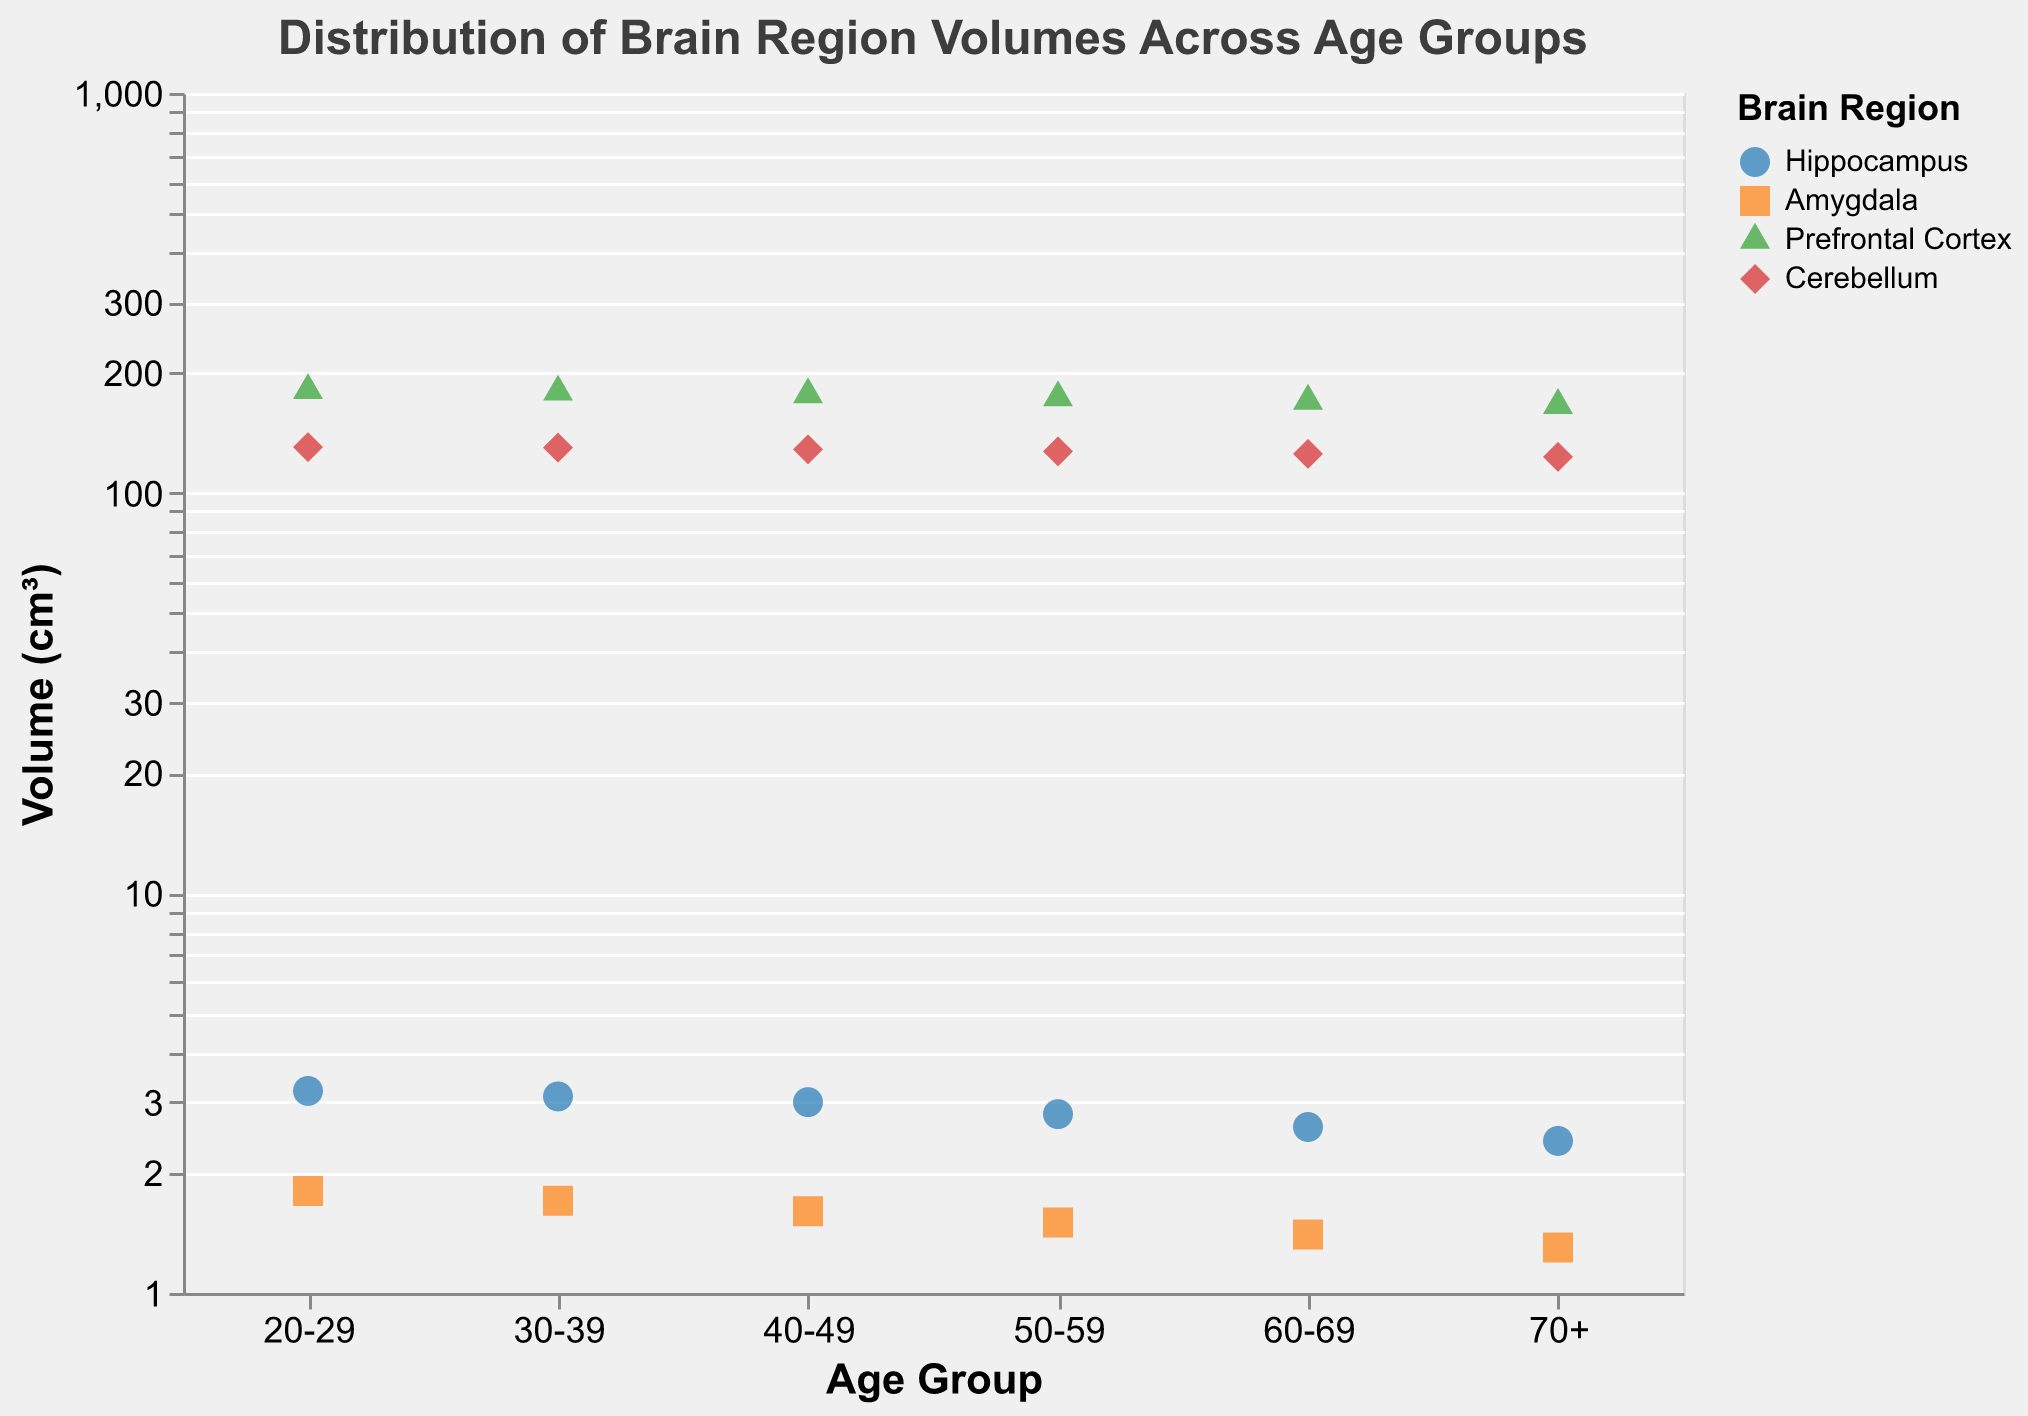How many brain regions are shown for each age group? There are four distinct brain regions: Hippocampus, Amygdala, Prefrontal Cortex, and Cerebellum listed for each age group.
Answer: 4 Which age group has the largest hippocampus volume? To determine this, look at the Hippocampus data points across all age groups and identify which has the highest volume. The highest hippocampus volume is 3.2 cm³ in the 20-29 group.
Answer: 20-29 What is the smallest amygdala volume in the plot? Compare the volumes of the Amygdala across all age groups to find the minimum value, which is 1.3 cm³ in the 70+ group.
Answer: 1.3 cm³ How do the volumes of the Prefrontal Cortex change as age increases? Observe the Prefrontal Cortex volumes across age groups. The volumes decrease as age increases: 180.5 cm³ (20-29), 178.9 cm³ (30-39), 176.2 cm³ (40-49), 173.1 cm³ (50-59), 169.8 cm³ (60-69), and 165.7 cm³ (70+).
Answer: They decrease Which brain region shows the most significant decrease in volume from age group 20-29 to age group 70+? Calculate the difference in volume for each brain region between the 20-29 and 70+ age groups: Hippocampus (3.2 - 2.4 = 0.8 cm³), Amygdala (1.8 - 1.3 = 0.5 cm³), Prefrontal Cortex (180.5 - 165.7 = 14.8 cm³), Cerebellum (130.2 - 123.1 = 7.1 cm³). The most significant decrease is for the Prefrontal Cortex with a change of 14.8 cm³.
Answer: Prefrontal Cortex Between which consecutive age groups is the decrease in Cerebellum volume the highest? Calculate the differences in Cerebellum volume between consecutive age groups: 20-29 to 30-39 (130.2 - 129.8 = 0.4 cm³), 30-39 to 40-49 (129.8 - 128.5 = 1.3 cm³), 40-49 to 50-59 (128.5 - 127.0 = 1.5 cm³), 50-59 to 60-69 (127.0 - 125.3 = 1.7 cm³), 60-69 to 70+ (125.3 - 123.1 = 2.2 cm³). The highest decrease is between 60-69 and 70+ with a change of 2.2 cm³.
Answer: 60-69 to 70+ What trend do you observe in the hippocampus volume across different age groups? The hippocampus volume shows a decreasing trend: 3.2 cm³ (20-29), 3.1 cm³ (30-39), 3.0 cm³ (40-49), 2.8 cm³ (50-59), 2.6 cm³ (60-69), and 2.4 cm³ (70+).
Answer: Decreasing trend Does any brain region maintain a constant volume across age groups? By inspecting the plot, we observe that none of the brain regions maintain a constant volume, as all show some degree of fluctuation across the different age groups.
Answer: No 